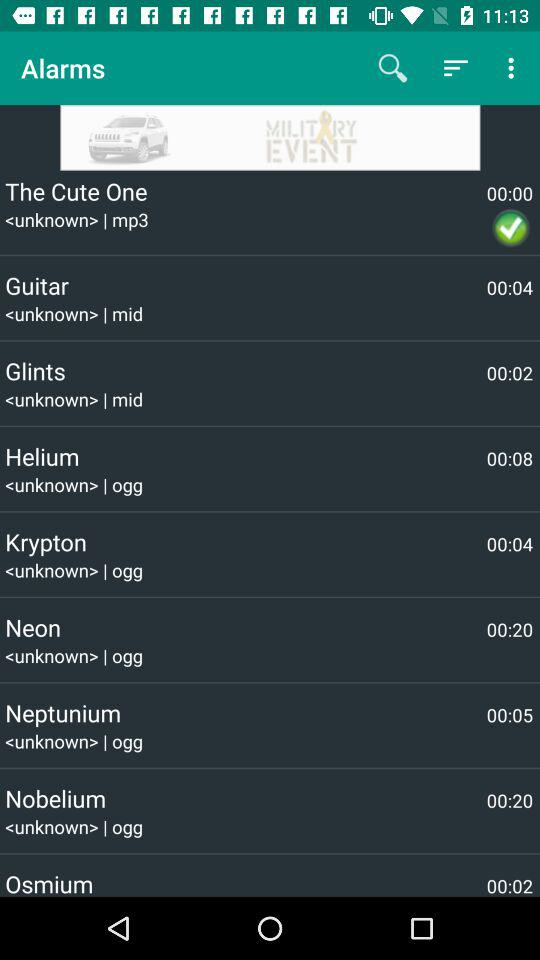What is the duration of "Neon"? The duration of "Neon" is 00:20. 